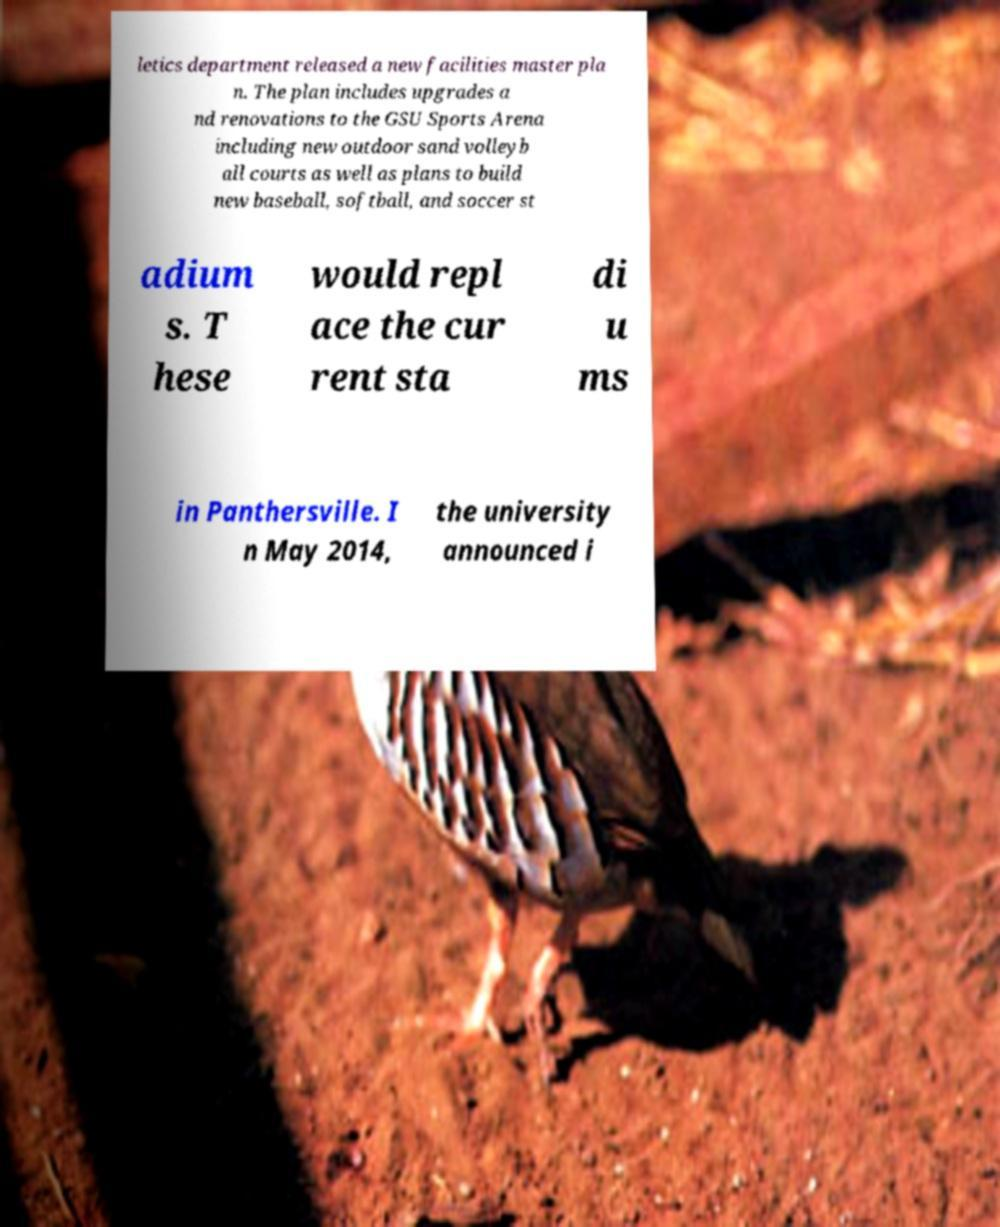Please identify and transcribe the text found in this image. letics department released a new facilities master pla n. The plan includes upgrades a nd renovations to the GSU Sports Arena including new outdoor sand volleyb all courts as well as plans to build new baseball, softball, and soccer st adium s. T hese would repl ace the cur rent sta di u ms in Panthersville. I n May 2014, the university announced i 